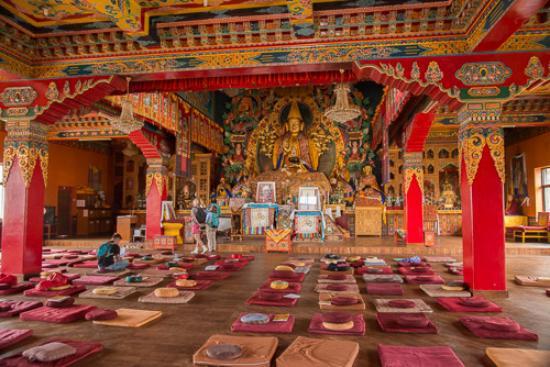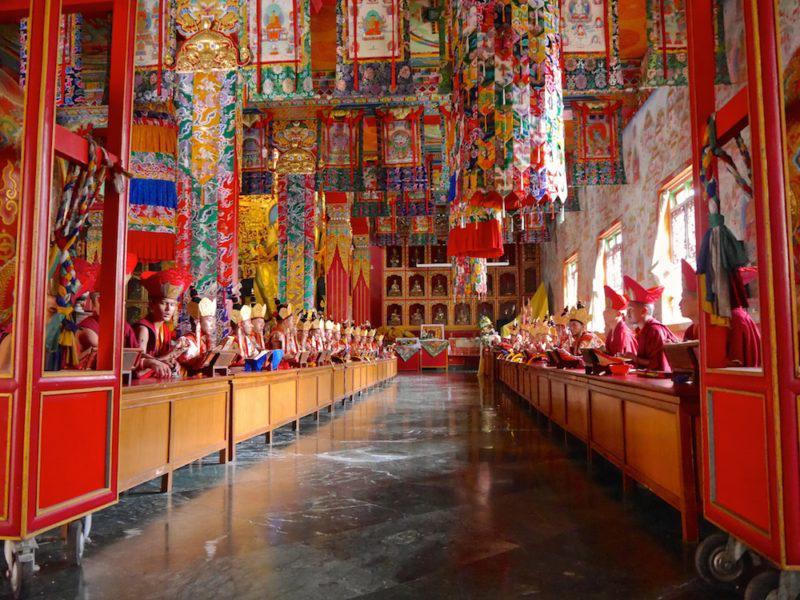The first image is the image on the left, the second image is the image on the right. For the images shown, is this caption "Both images are of the inside of a room." true? Answer yes or no. Yes. 